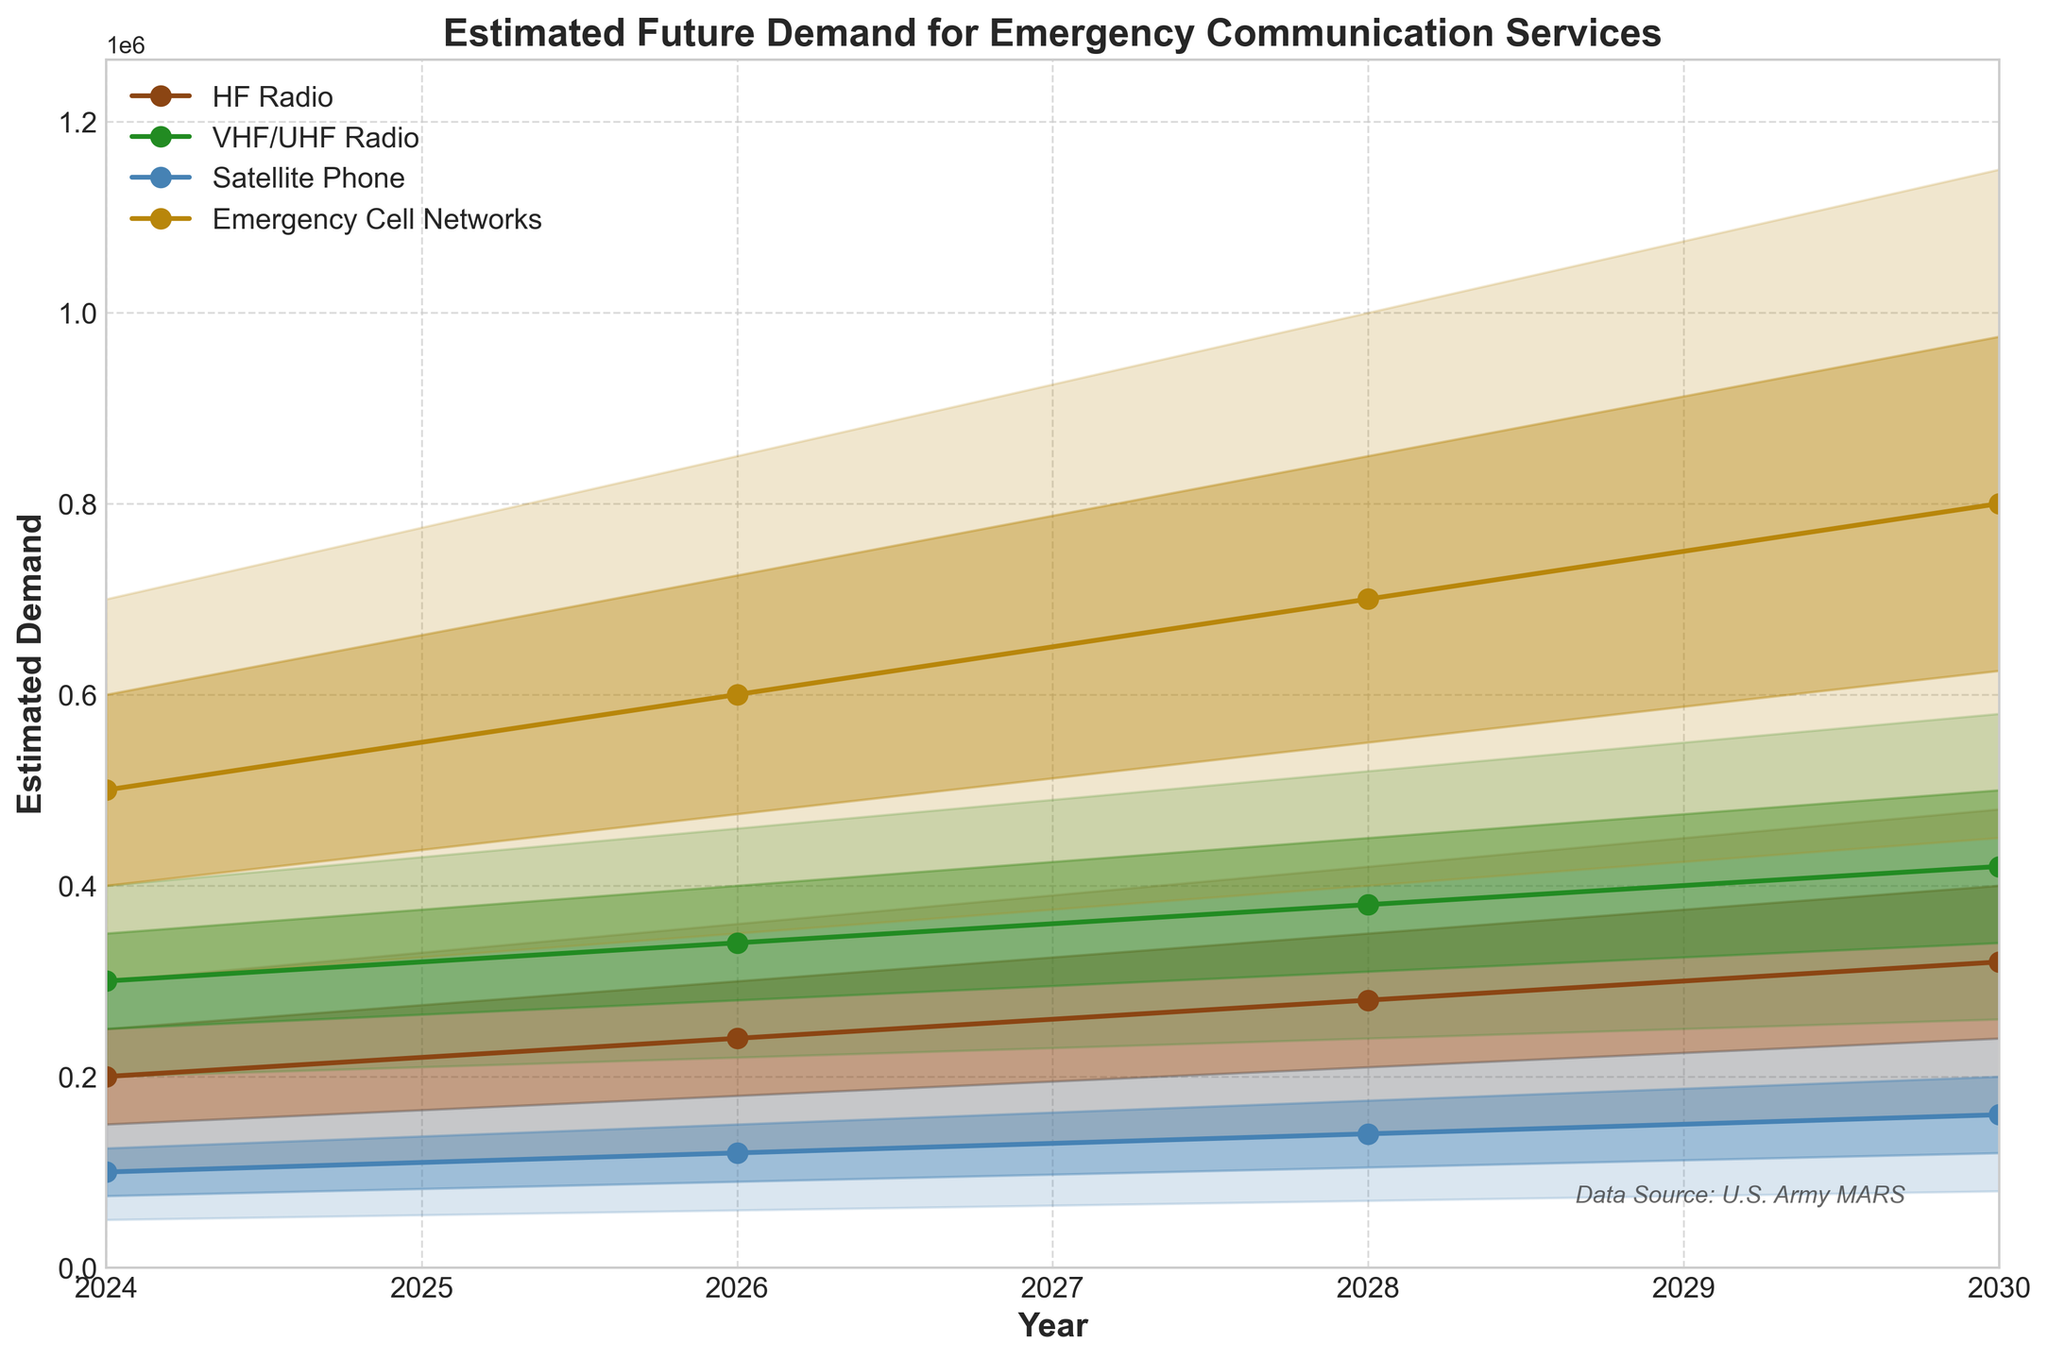What year has the highest mid estimate for HF Radio? Look at the mid estimate line (solid line) for HF Radio and identify the highest point. This occurs in 2030.
Answer: 2030 What is the range of estimated demand for Emergency Cell Networks in 2028? The range is defined by the lowest and highest estimate. For Emergency Cell Networks in 2028, the low estimate is 400,000 and the high estimate is 1,000,000.
Answer: 600,000 How does the mid estimate of VHF/UHF Radio in 2026 compare to that in 2030? Compare the mid estimates (the solid lines) for VHF/UHF Radio in 2026 and 2030. In 2026, the mid estimate is 340,000; in 2030, it is 420,000.
Answer: The mid estimate increases by 80,000 What trends can you observe for Satellite Phone demand from 2024 to 2030? Follow the mid estimate line for Satellite Phone from 2024 to 2030. The mid estimate gradually increases from 100,000 in 2024 to 160,000 in 2030.
Answer: Increasing trend Which communication method shows the greatest variability in demand estimates in 2026? Compare the width of the fan (the area between the low and high estimates) for each method in 2026. Emergency Cell Networks have the widest spread between 350,000 and 850,000.
Answer: Emergency Cell Networks On average, how much does the high estimate for HF Radio increase every two years? For HF Radio, calculate the differences in high estimates between consecutive years: 2026 (360,000) - 2024 (300,000) = 60,000, 2028 (420,000) - 2026 (360,000) = 60,000, 2030 (480,000) - 2028 (420,000) = 60,000. Average increase = (60,000 + 60,000 + 60,000) / 3 = 60,000.
Answer: 60,000 Which communication method has the smallest mid estimate in 2024? Compare the mid estimates for all communication methods in 2024. Satellite Phone has the smallest mid estimate of 100,000.
Answer: Satellite Phone 